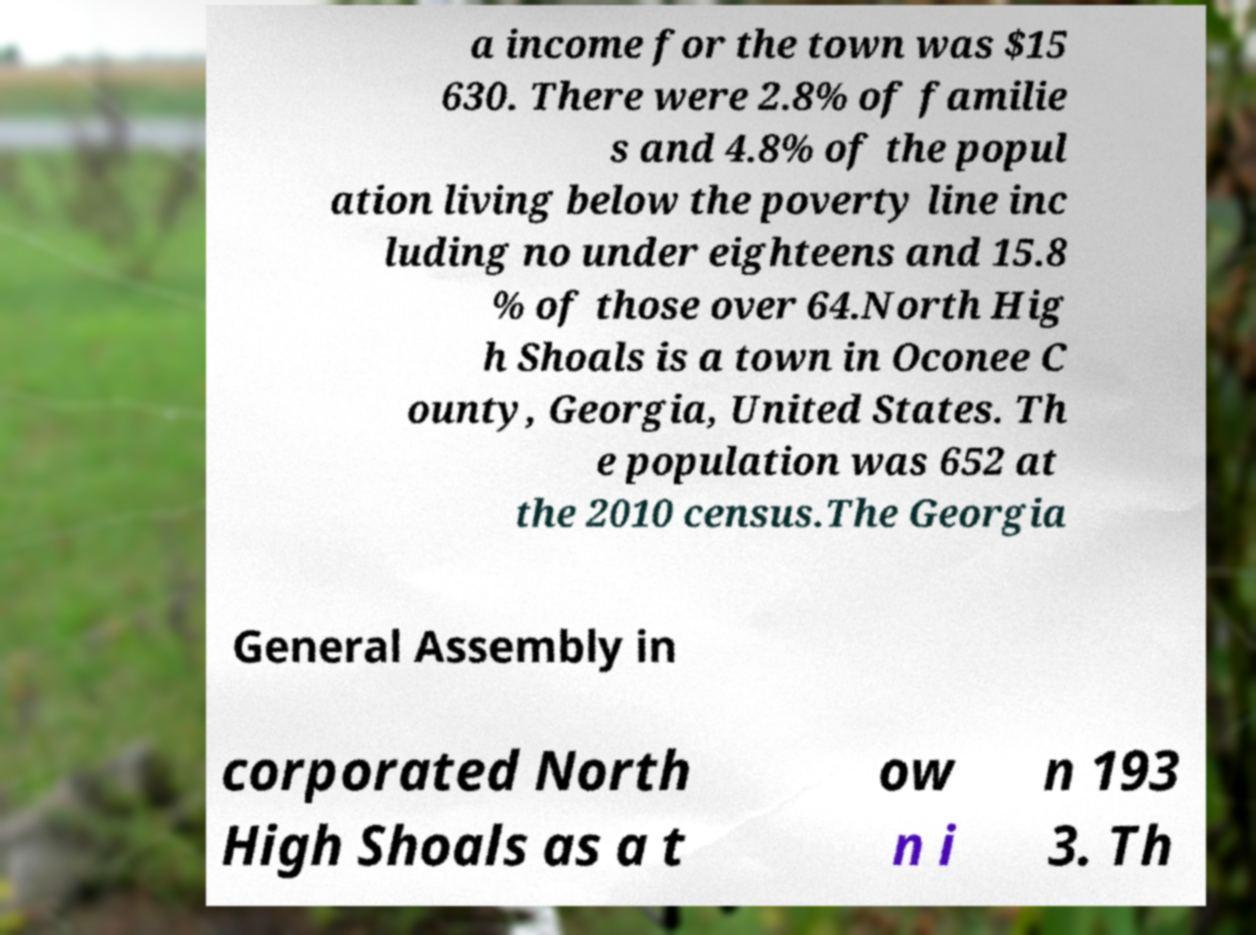Can you read and provide the text displayed in the image?This photo seems to have some interesting text. Can you extract and type it out for me? a income for the town was $15 630. There were 2.8% of familie s and 4.8% of the popul ation living below the poverty line inc luding no under eighteens and 15.8 % of those over 64.North Hig h Shoals is a town in Oconee C ounty, Georgia, United States. Th e population was 652 at the 2010 census.The Georgia General Assembly in corporated North High Shoals as a t ow n i n 193 3. Th 